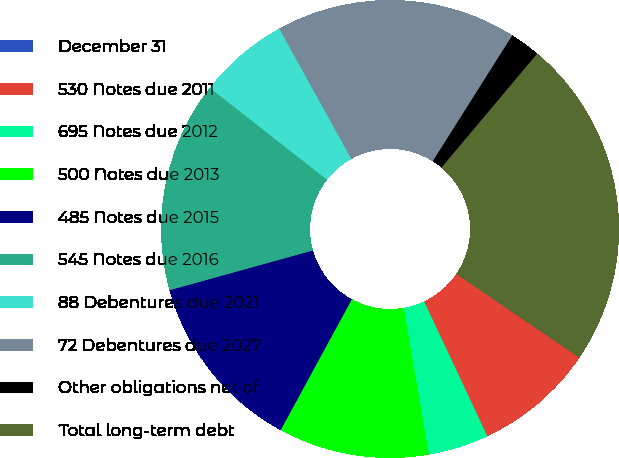Convert chart to OTSL. <chart><loc_0><loc_0><loc_500><loc_500><pie_chart><fcel>December 31<fcel>530 Notes due 2011<fcel>695 Notes due 2012<fcel>500 Notes due 2013<fcel>485 Notes due 2015<fcel>545 Notes due 2016<fcel>88 Debentures due 2021<fcel>72 Debentures due 2027<fcel>Other obligations net of<fcel>Total long-term debt<nl><fcel>0.02%<fcel>8.51%<fcel>4.27%<fcel>10.64%<fcel>12.76%<fcel>14.88%<fcel>6.39%<fcel>17.0%<fcel>2.15%<fcel>23.37%<nl></chart> 